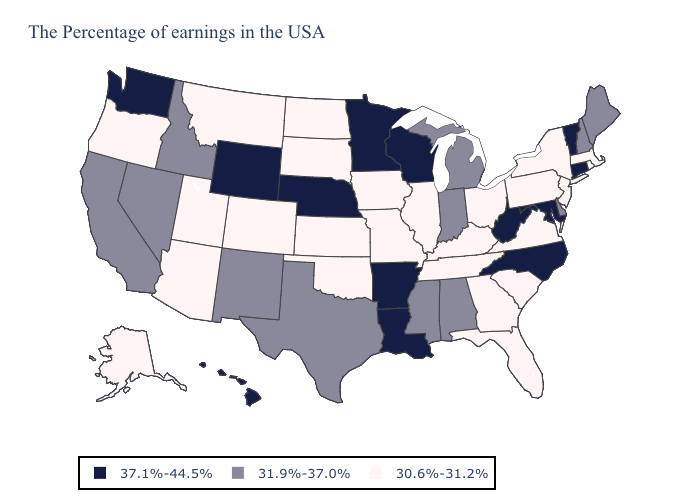Name the states that have a value in the range 30.6%-31.2%?
Be succinct. Massachusetts, Rhode Island, New York, New Jersey, Pennsylvania, Virginia, South Carolina, Ohio, Florida, Georgia, Kentucky, Tennessee, Illinois, Missouri, Iowa, Kansas, Oklahoma, South Dakota, North Dakota, Colorado, Utah, Montana, Arizona, Oregon, Alaska. Does Kansas have the lowest value in the MidWest?
Answer briefly. Yes. What is the highest value in the MidWest ?
Short answer required. 37.1%-44.5%. What is the value of Kentucky?
Give a very brief answer. 30.6%-31.2%. Does Delaware have the same value as West Virginia?
Answer briefly. No. Does the first symbol in the legend represent the smallest category?
Short answer required. No. Among the states that border Pennsylvania , does Ohio have the lowest value?
Short answer required. Yes. Name the states that have a value in the range 31.9%-37.0%?
Be succinct. Maine, New Hampshire, Delaware, Michigan, Indiana, Alabama, Mississippi, Texas, New Mexico, Idaho, Nevada, California. Does Texas have the same value as Illinois?
Concise answer only. No. What is the value of Indiana?
Answer briefly. 31.9%-37.0%. Name the states that have a value in the range 30.6%-31.2%?
Concise answer only. Massachusetts, Rhode Island, New York, New Jersey, Pennsylvania, Virginia, South Carolina, Ohio, Florida, Georgia, Kentucky, Tennessee, Illinois, Missouri, Iowa, Kansas, Oklahoma, South Dakota, North Dakota, Colorado, Utah, Montana, Arizona, Oregon, Alaska. Name the states that have a value in the range 31.9%-37.0%?
Quick response, please. Maine, New Hampshire, Delaware, Michigan, Indiana, Alabama, Mississippi, Texas, New Mexico, Idaho, Nevada, California. What is the lowest value in states that border West Virginia?
Quick response, please. 30.6%-31.2%. Name the states that have a value in the range 30.6%-31.2%?
Concise answer only. Massachusetts, Rhode Island, New York, New Jersey, Pennsylvania, Virginia, South Carolina, Ohio, Florida, Georgia, Kentucky, Tennessee, Illinois, Missouri, Iowa, Kansas, Oklahoma, South Dakota, North Dakota, Colorado, Utah, Montana, Arizona, Oregon, Alaska. Name the states that have a value in the range 30.6%-31.2%?
Be succinct. Massachusetts, Rhode Island, New York, New Jersey, Pennsylvania, Virginia, South Carolina, Ohio, Florida, Georgia, Kentucky, Tennessee, Illinois, Missouri, Iowa, Kansas, Oklahoma, South Dakota, North Dakota, Colorado, Utah, Montana, Arizona, Oregon, Alaska. 